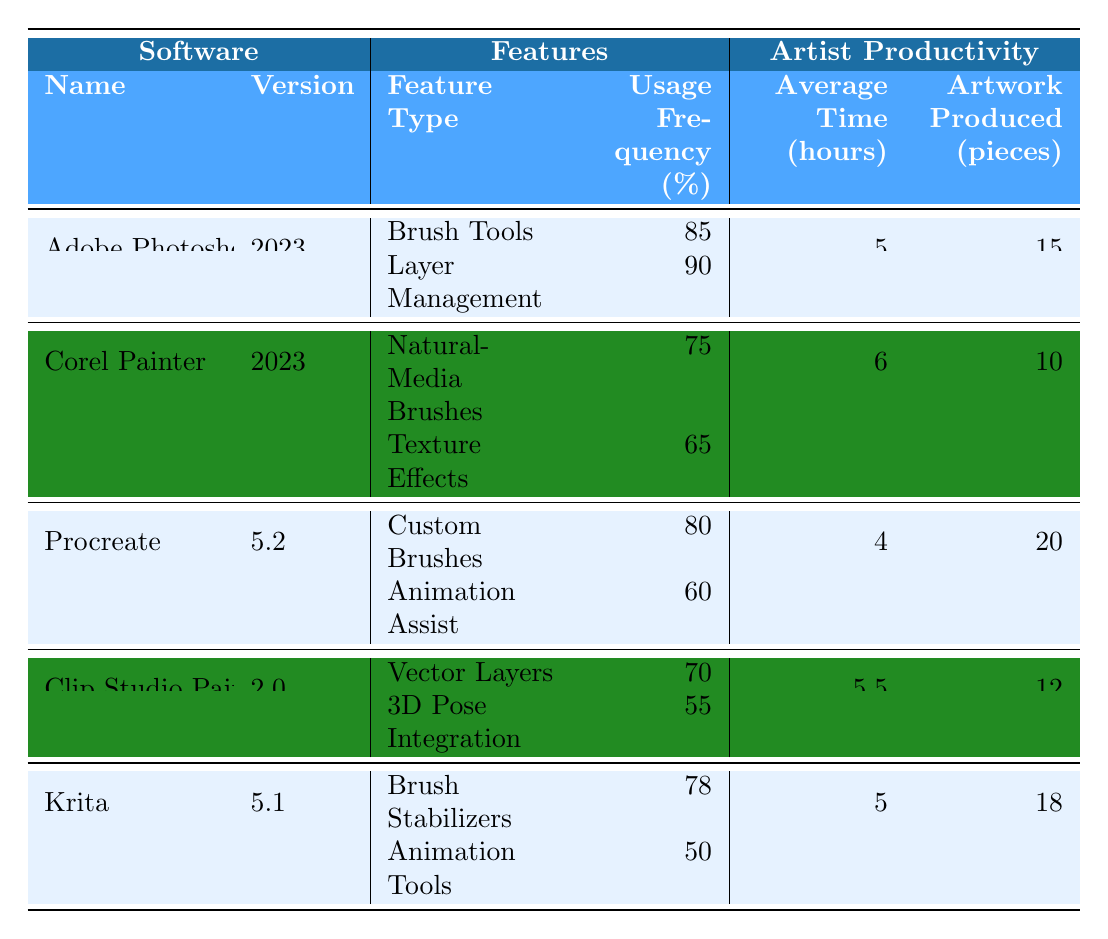What is the usage frequency of Brush Tools in Adobe Photoshop? The table lists the usage frequency of Brush Tools under Adobe Photoshop in the Features section, which is stated as 85%.
Answer: 85% Which software produced the most pieces of artwork? By comparing the Artwork Produced column, Procreate has the highest number at 20 pieces.
Answer: Procreate What is the average time spent using Corel Painter? The table states that the average time for Corel Painter, found in the Artist Productivity section, is 6 hours.
Answer: 6 hours Is the usage frequency of Layer Management higher than that of Texture Effects in Corel Painter? In Corel Painter, Layer Management's frequency is not listed, so we consider that the information for Layer Management belongs to Adobe Photoshop (with 90%). For Texture Effects in Corel Painter, the usage frequency is 65%, thus confirming that Layer Management's frequency is higher.
Answer: Yes What is the difference in average time spent between Procreate and Corel Painter? Procreate has an average time of 4 hours while Corel Painter has 6 hours. The difference is calculated as 6 - 4 = 2 hours.
Answer: 2 hours On average, how many pieces of artwork were produced per hour in Krita? Krita produced 18 pieces in 5 hours. Therefore, the average is calculated as 18 / 5 = 3.6 pieces per hour.
Answer: 3.6 pieces per hour Did any of the software have a usage frequency of less than 70% for at least one feature? Looking at the Feature Usage Frequency for each software, Corel Painter has Texture Effects at 65%, which is indeed below 70%.
Answer: Yes Which software has the highest average time per artwork produced? To find this, we must calculate the average time spent per artwork produced for all software. For Adobe Photoshop, it is 5/15 = 0.33 hours per piece; for Corel Painter, it's 6/10 = 0.6 hours; for Procreate, it's 4/20 = 0.2 hours; for Clip Studio Paint, it's 5.5/12 = 0.46 hours; for Krita, it's 5/18 = 0.28 hours. The highest of these is Corel Painter at 0.6 hours per piece.
Answer: Corel Painter Is there a correlation between the usage frequency of Animation Tools and the number of artworks produced in Krita? The usage frequency of Animation Tools in Krita is 50%. The artworks produced are 18 pieces. Since the frequency is relatively lower while the artwork production is high, there does not appear to be a positive correlation based on this data alone.
Answer: No 